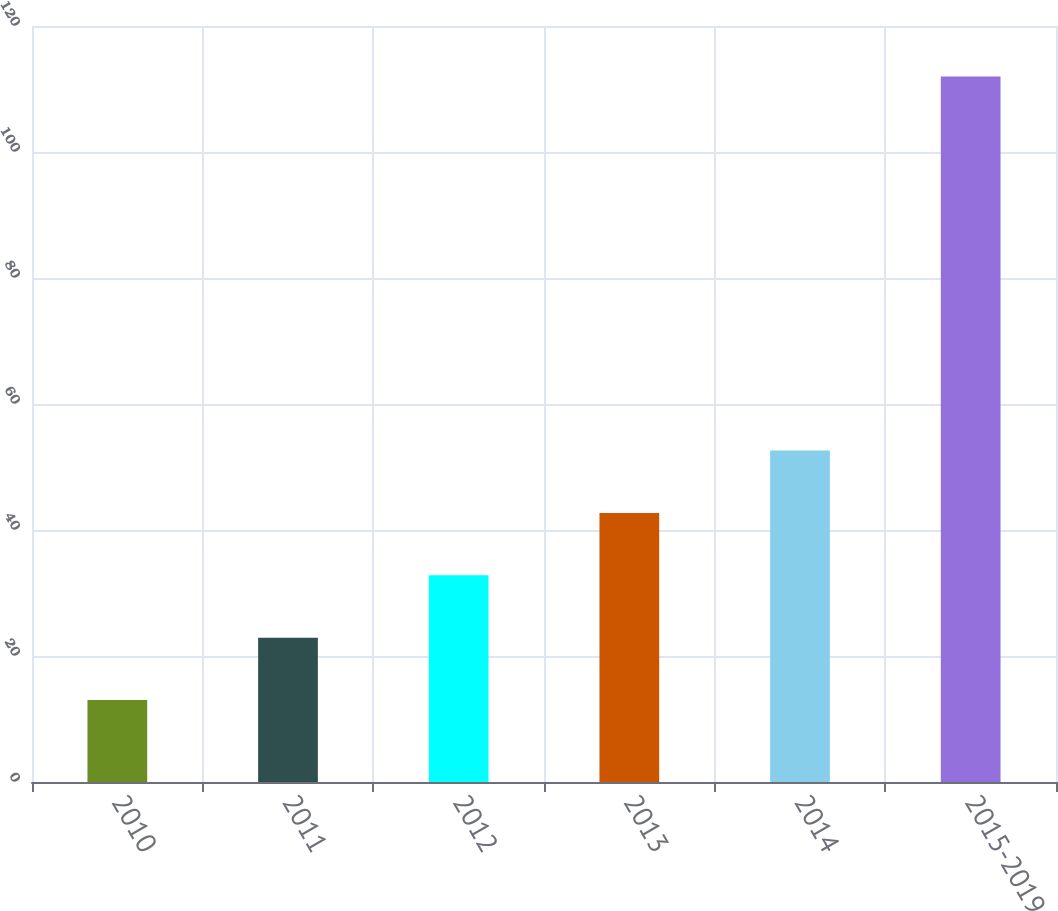Convert chart. <chart><loc_0><loc_0><loc_500><loc_500><bar_chart><fcel>2010<fcel>2011<fcel>2012<fcel>2013<fcel>2014<fcel>2015-2019<nl><fcel>13<fcel>22.9<fcel>32.8<fcel>42.7<fcel>52.6<fcel>112<nl></chart> 